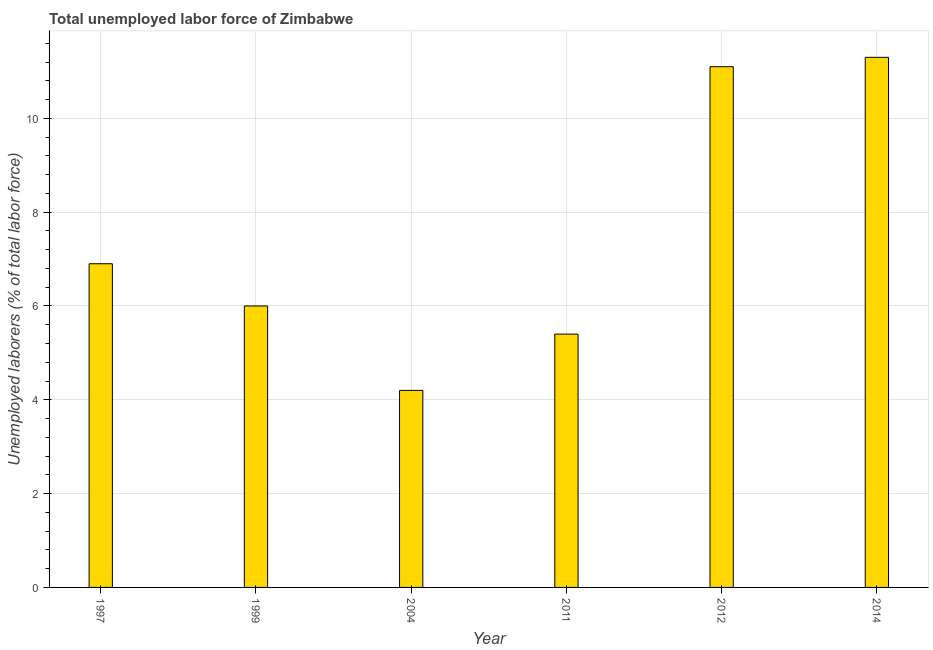Does the graph contain any zero values?
Keep it short and to the point. No. What is the title of the graph?
Give a very brief answer. Total unemployed labor force of Zimbabwe. What is the label or title of the Y-axis?
Offer a terse response. Unemployed laborers (% of total labor force). What is the total unemployed labour force in 1999?
Your answer should be very brief. 6. Across all years, what is the maximum total unemployed labour force?
Ensure brevity in your answer.  11.3. Across all years, what is the minimum total unemployed labour force?
Your response must be concise. 4.2. In which year was the total unemployed labour force maximum?
Your response must be concise. 2014. What is the sum of the total unemployed labour force?
Make the answer very short. 44.9. What is the average total unemployed labour force per year?
Offer a terse response. 7.48. What is the median total unemployed labour force?
Offer a terse response. 6.45. In how many years, is the total unemployed labour force greater than 4 %?
Keep it short and to the point. 6. Do a majority of the years between 2014 and 2004 (inclusive) have total unemployed labour force greater than 10 %?
Your response must be concise. Yes. What is the ratio of the total unemployed labour force in 2004 to that in 2012?
Offer a very short reply. 0.38. Is the total unemployed labour force in 2011 less than that in 2012?
Ensure brevity in your answer.  Yes. What is the difference between the highest and the lowest total unemployed labour force?
Keep it short and to the point. 7.1. In how many years, is the total unemployed labour force greater than the average total unemployed labour force taken over all years?
Ensure brevity in your answer.  2. Are all the bars in the graph horizontal?
Your response must be concise. No. How many years are there in the graph?
Keep it short and to the point. 6. What is the Unemployed laborers (% of total labor force) in 1997?
Offer a very short reply. 6.9. What is the Unemployed laborers (% of total labor force) in 2004?
Offer a terse response. 4.2. What is the Unemployed laborers (% of total labor force) of 2011?
Your response must be concise. 5.4. What is the Unemployed laborers (% of total labor force) in 2012?
Make the answer very short. 11.1. What is the Unemployed laborers (% of total labor force) in 2014?
Ensure brevity in your answer.  11.3. What is the difference between the Unemployed laborers (% of total labor force) in 1997 and 2004?
Your answer should be very brief. 2.7. What is the difference between the Unemployed laborers (% of total labor force) in 1999 and 2004?
Offer a very short reply. 1.8. What is the difference between the Unemployed laborers (% of total labor force) in 1999 and 2012?
Your answer should be compact. -5.1. What is the difference between the Unemployed laborers (% of total labor force) in 1999 and 2014?
Provide a succinct answer. -5.3. What is the difference between the Unemployed laborers (% of total labor force) in 2004 and 2011?
Keep it short and to the point. -1.2. What is the difference between the Unemployed laborers (% of total labor force) in 2004 and 2012?
Ensure brevity in your answer.  -6.9. What is the difference between the Unemployed laborers (% of total labor force) in 2011 and 2012?
Give a very brief answer. -5.7. What is the difference between the Unemployed laborers (% of total labor force) in 2012 and 2014?
Make the answer very short. -0.2. What is the ratio of the Unemployed laborers (% of total labor force) in 1997 to that in 1999?
Your response must be concise. 1.15. What is the ratio of the Unemployed laborers (% of total labor force) in 1997 to that in 2004?
Provide a succinct answer. 1.64. What is the ratio of the Unemployed laborers (% of total labor force) in 1997 to that in 2011?
Provide a short and direct response. 1.28. What is the ratio of the Unemployed laborers (% of total labor force) in 1997 to that in 2012?
Provide a short and direct response. 0.62. What is the ratio of the Unemployed laborers (% of total labor force) in 1997 to that in 2014?
Provide a short and direct response. 0.61. What is the ratio of the Unemployed laborers (% of total labor force) in 1999 to that in 2004?
Keep it short and to the point. 1.43. What is the ratio of the Unemployed laborers (% of total labor force) in 1999 to that in 2011?
Ensure brevity in your answer.  1.11. What is the ratio of the Unemployed laborers (% of total labor force) in 1999 to that in 2012?
Provide a succinct answer. 0.54. What is the ratio of the Unemployed laborers (% of total labor force) in 1999 to that in 2014?
Provide a short and direct response. 0.53. What is the ratio of the Unemployed laborers (% of total labor force) in 2004 to that in 2011?
Keep it short and to the point. 0.78. What is the ratio of the Unemployed laborers (% of total labor force) in 2004 to that in 2012?
Your answer should be compact. 0.38. What is the ratio of the Unemployed laborers (% of total labor force) in 2004 to that in 2014?
Make the answer very short. 0.37. What is the ratio of the Unemployed laborers (% of total labor force) in 2011 to that in 2012?
Offer a very short reply. 0.49. What is the ratio of the Unemployed laborers (% of total labor force) in 2011 to that in 2014?
Offer a terse response. 0.48. 